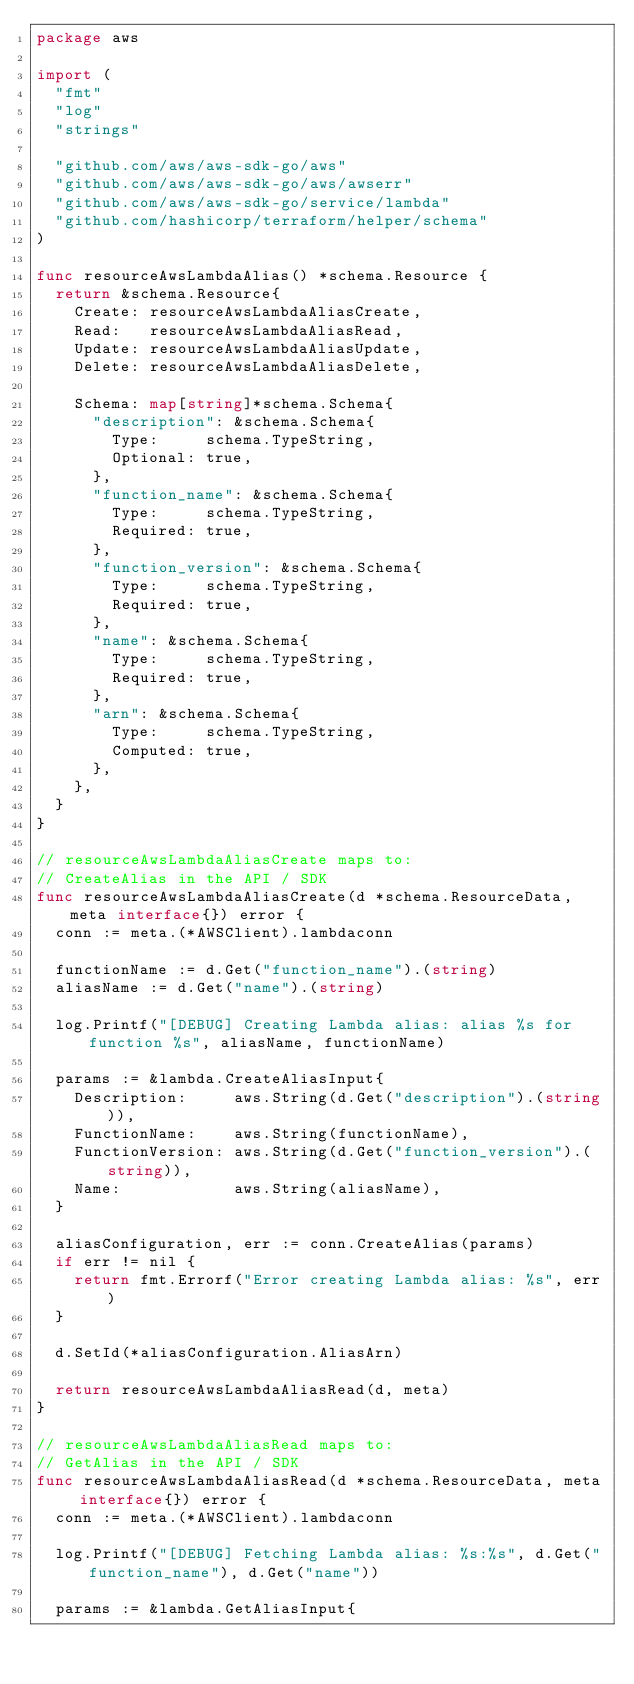Convert code to text. <code><loc_0><loc_0><loc_500><loc_500><_Go_>package aws

import (
	"fmt"
	"log"
	"strings"

	"github.com/aws/aws-sdk-go/aws"
	"github.com/aws/aws-sdk-go/aws/awserr"
	"github.com/aws/aws-sdk-go/service/lambda"
	"github.com/hashicorp/terraform/helper/schema"
)

func resourceAwsLambdaAlias() *schema.Resource {
	return &schema.Resource{
		Create: resourceAwsLambdaAliasCreate,
		Read:   resourceAwsLambdaAliasRead,
		Update: resourceAwsLambdaAliasUpdate,
		Delete: resourceAwsLambdaAliasDelete,

		Schema: map[string]*schema.Schema{
			"description": &schema.Schema{
				Type:     schema.TypeString,
				Optional: true,
			},
			"function_name": &schema.Schema{
				Type:     schema.TypeString,
				Required: true,
			},
			"function_version": &schema.Schema{
				Type:     schema.TypeString,
				Required: true,
			},
			"name": &schema.Schema{
				Type:     schema.TypeString,
				Required: true,
			},
			"arn": &schema.Schema{
				Type:     schema.TypeString,
				Computed: true,
			},
		},
	}
}

// resourceAwsLambdaAliasCreate maps to:
// CreateAlias in the API / SDK
func resourceAwsLambdaAliasCreate(d *schema.ResourceData, meta interface{}) error {
	conn := meta.(*AWSClient).lambdaconn

	functionName := d.Get("function_name").(string)
	aliasName := d.Get("name").(string)

	log.Printf("[DEBUG] Creating Lambda alias: alias %s for function %s", aliasName, functionName)

	params := &lambda.CreateAliasInput{
		Description:     aws.String(d.Get("description").(string)),
		FunctionName:    aws.String(functionName),
		FunctionVersion: aws.String(d.Get("function_version").(string)),
		Name:            aws.String(aliasName),
	}

	aliasConfiguration, err := conn.CreateAlias(params)
	if err != nil {
		return fmt.Errorf("Error creating Lambda alias: %s", err)
	}

	d.SetId(*aliasConfiguration.AliasArn)

	return resourceAwsLambdaAliasRead(d, meta)
}

// resourceAwsLambdaAliasRead maps to:
// GetAlias in the API / SDK
func resourceAwsLambdaAliasRead(d *schema.ResourceData, meta interface{}) error {
	conn := meta.(*AWSClient).lambdaconn

	log.Printf("[DEBUG] Fetching Lambda alias: %s:%s", d.Get("function_name"), d.Get("name"))

	params := &lambda.GetAliasInput{</code> 